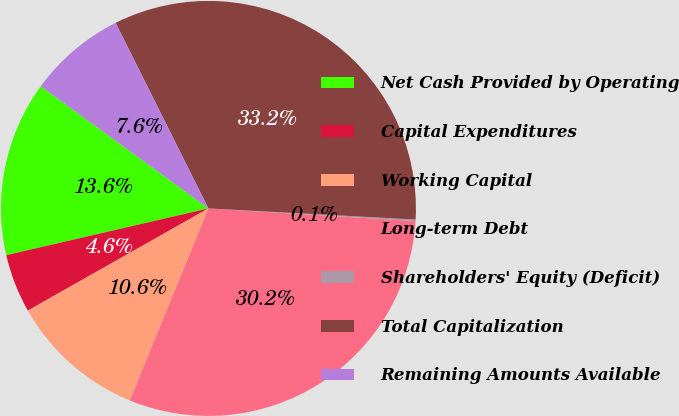Convert chart. <chart><loc_0><loc_0><loc_500><loc_500><pie_chart><fcel>Net Cash Provided by Operating<fcel>Capital Expenditures<fcel>Working Capital<fcel>Long-term Debt<fcel>Shareholders' Equity (Deficit)<fcel>Total Capitalization<fcel>Remaining Amounts Available<nl><fcel>13.64%<fcel>4.58%<fcel>10.62%<fcel>30.22%<fcel>0.12%<fcel>33.24%<fcel>7.6%<nl></chart> 